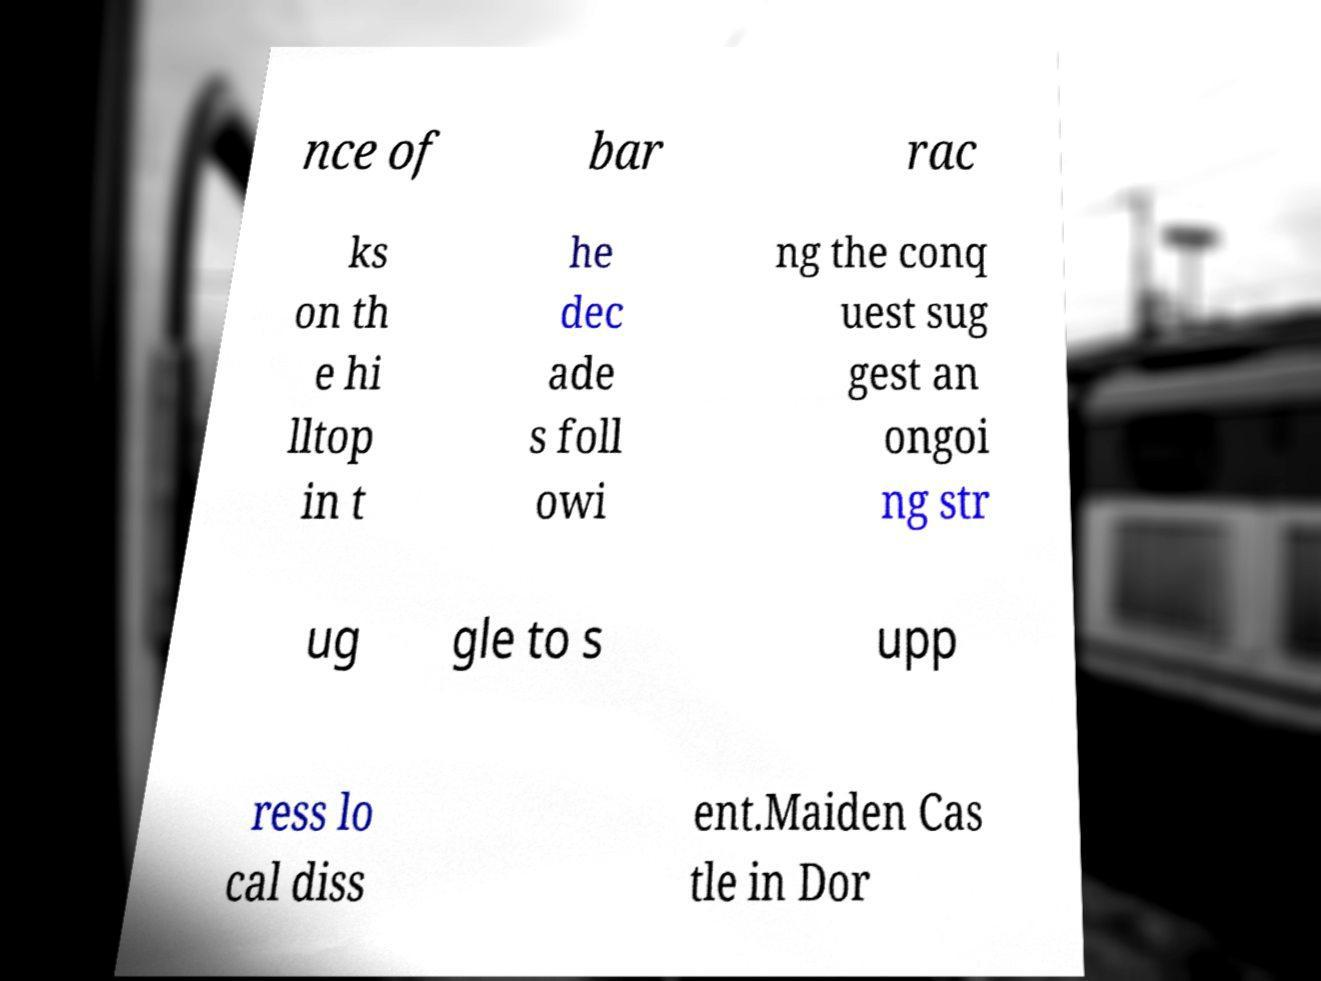Could you extract and type out the text from this image? nce of bar rac ks on th e hi lltop in t he dec ade s foll owi ng the conq uest sug gest an ongoi ng str ug gle to s upp ress lo cal diss ent.Maiden Cas tle in Dor 